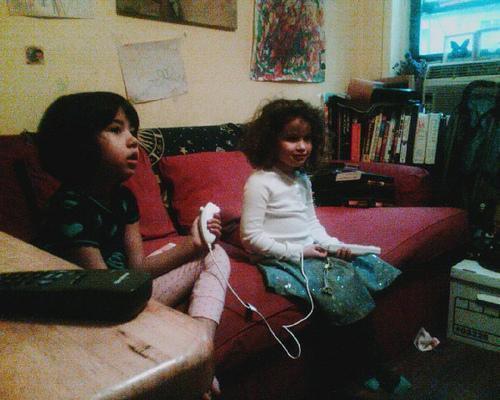How many controllers are the girls sharing?
Give a very brief answer. 1. How many people can you see?
Give a very brief answer. 2. How many blue ties are there?
Give a very brief answer. 0. 